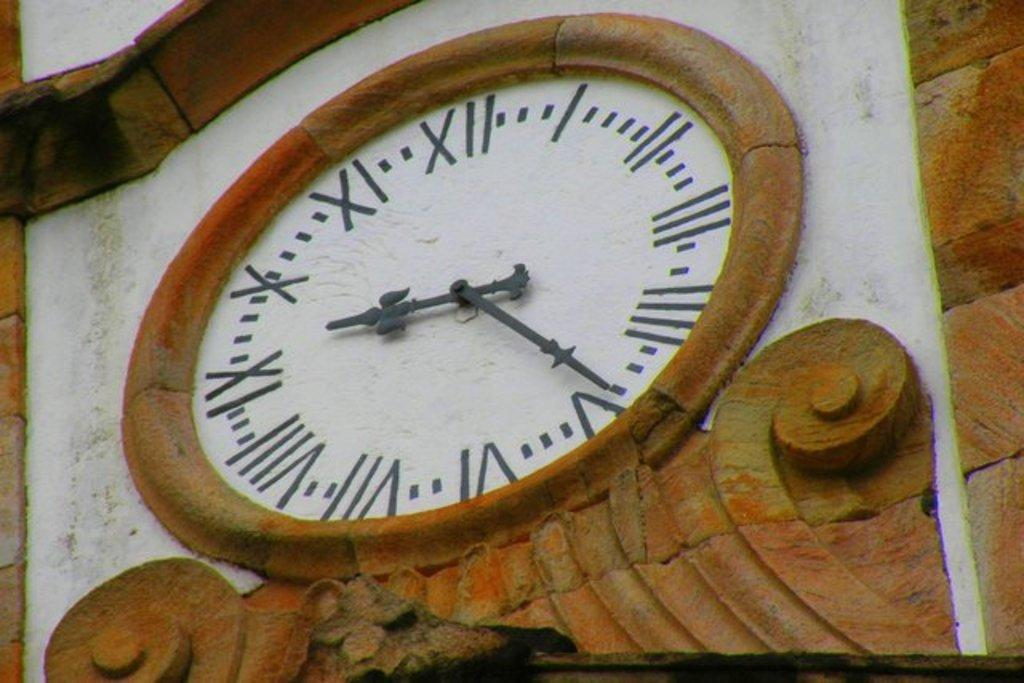What object can be seen in the image? There is a clock in the image. Where is the clock located? The clock is on a wall. What type of woman is the judge in the image? There is no woman or judge present in the image; it only features a clock on a wall. 